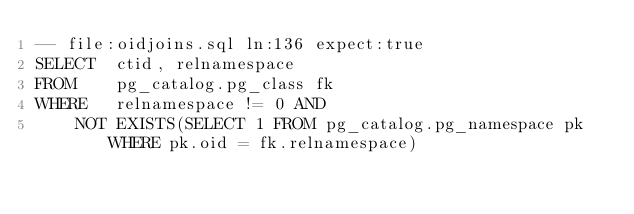<code> <loc_0><loc_0><loc_500><loc_500><_SQL_>-- file:oidjoins.sql ln:136 expect:true
SELECT	ctid, relnamespace
FROM	pg_catalog.pg_class fk
WHERE	relnamespace != 0 AND
	NOT EXISTS(SELECT 1 FROM pg_catalog.pg_namespace pk WHERE pk.oid = fk.relnamespace)
</code> 